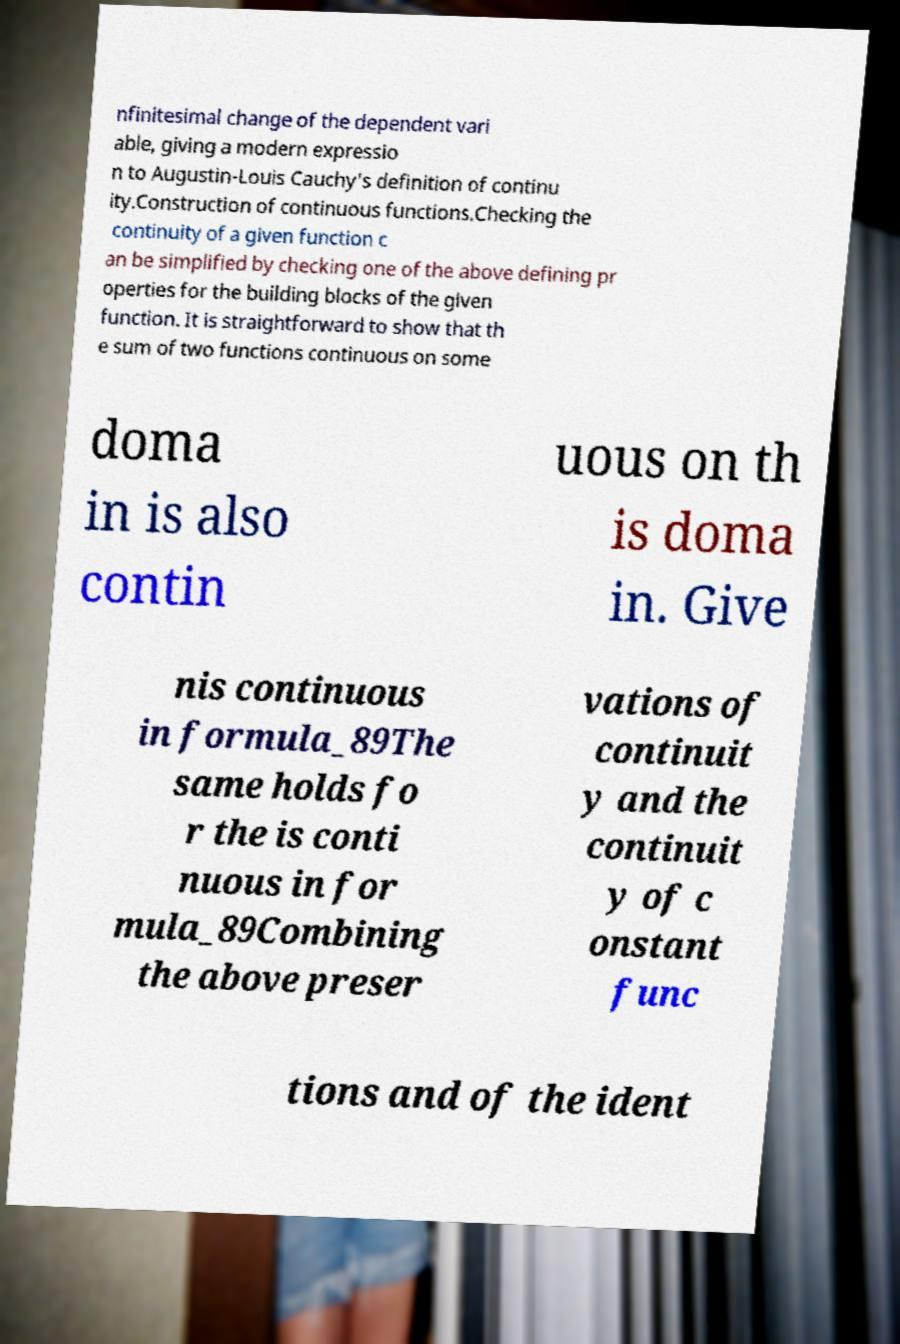What messages or text are displayed in this image? I need them in a readable, typed format. nfinitesimal change of the dependent vari able, giving a modern expressio n to Augustin-Louis Cauchy's definition of continu ity.Construction of continuous functions.Checking the continuity of a given function c an be simplified by checking one of the above defining pr operties for the building blocks of the given function. It is straightforward to show that th e sum of two functions continuous on some doma in is also contin uous on th is doma in. Give nis continuous in formula_89The same holds fo r the is conti nuous in for mula_89Combining the above preser vations of continuit y and the continuit y of c onstant func tions and of the ident 